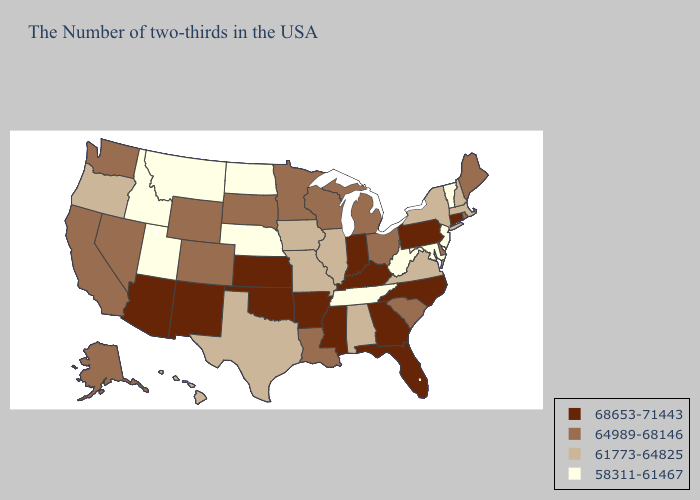What is the highest value in the USA?
Be succinct. 68653-71443. Does Connecticut have the lowest value in the USA?
Concise answer only. No. What is the highest value in states that border Kentucky?
Answer briefly. 68653-71443. Name the states that have a value in the range 64989-68146?
Quick response, please. Maine, Rhode Island, Delaware, South Carolina, Ohio, Michigan, Wisconsin, Louisiana, Minnesota, South Dakota, Wyoming, Colorado, Nevada, California, Washington, Alaska. Does the first symbol in the legend represent the smallest category?
Keep it brief. No. What is the value of Hawaii?
Short answer required. 61773-64825. What is the highest value in states that border Kansas?
Answer briefly. 68653-71443. Is the legend a continuous bar?
Answer briefly. No. What is the highest value in states that border Virginia?
Short answer required. 68653-71443. What is the value of Massachusetts?
Answer briefly. 61773-64825. What is the lowest value in states that border Pennsylvania?
Concise answer only. 58311-61467. Does Delaware have a higher value than Kansas?
Be succinct. No. What is the highest value in the South ?
Answer briefly. 68653-71443. Which states have the lowest value in the USA?
Keep it brief. Vermont, New Jersey, Maryland, West Virginia, Tennessee, Nebraska, North Dakota, Utah, Montana, Idaho. Does North Dakota have the lowest value in the USA?
Be succinct. Yes. 